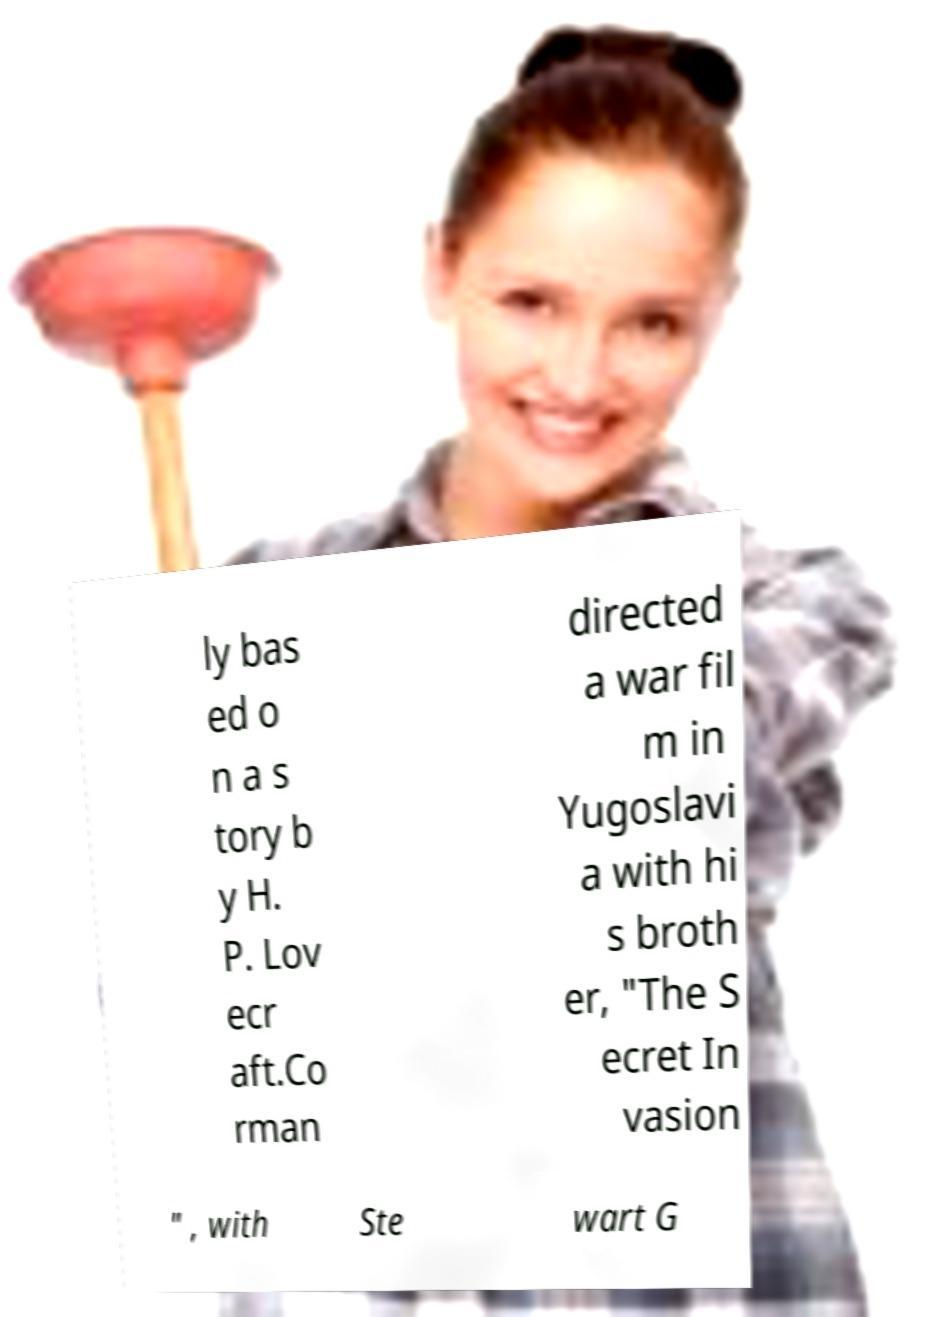Can you read and provide the text displayed in the image?This photo seems to have some interesting text. Can you extract and type it out for me? ly bas ed o n a s tory b y H. P. Lov ecr aft.Co rman directed a war fil m in Yugoslavi a with hi s broth er, "The S ecret In vasion " , with Ste wart G 